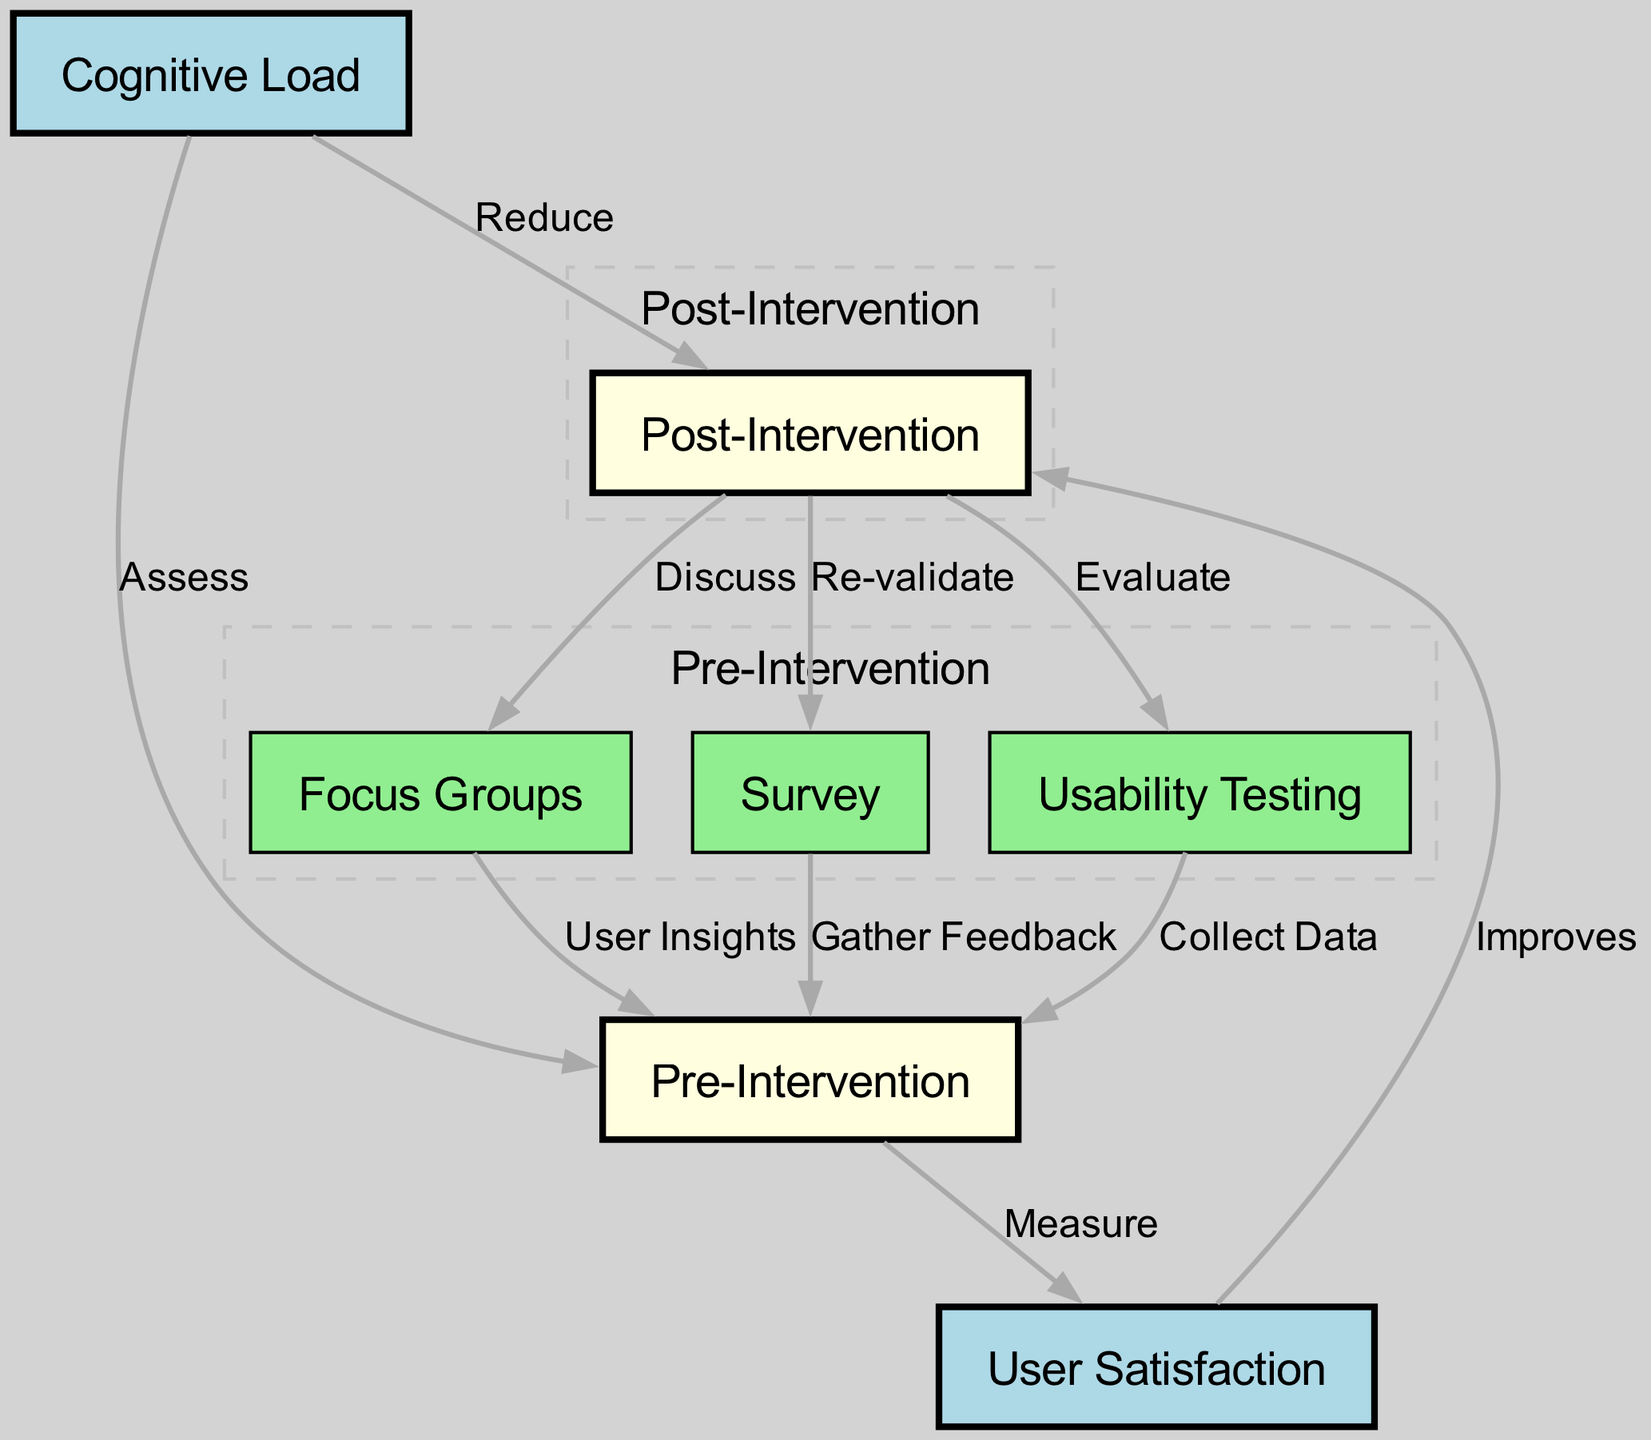What is the label of the node related to user satisfaction? The node related to user satisfaction is labeled "User Satisfaction", as indicated in the diagram with the specific node designation for user satisfaction.
Answer: User Satisfaction How many nodes are in the diagram? By counting all the nodes listed under "nodes", there are 6 nodes in total: User Satisfaction, Pre-Intervention, Post-Intervention, Cognitive Load, Usability Testing, Focus Groups, and Survey.
Answer: 6 What relationship exists between pre-intervention and user satisfaction? The edge connecting the pre-intervention node to the user satisfaction node is labeled "Measure", indicating that pre-intervention activities involve measuring user satisfaction.
Answer: Measure Which techniques collect data before the intervention? The nodes usability testing, focus groups, and survey are all connected to pre-intervention, indicating that they are techniques used to collect data prior to the intervention.
Answer: Usability Testing, Focus Groups, Survey How does cognitive load relate to post-intervention? The edge from cognitive load to post-intervention is labeled "Reduce", indicating that after the intervention, the aim is to reduce cognitive load for users, connecting both concepts.
Answer: Reduce What is evaluated after the post-intervention phase? The node labeled usability testing is connected to post-intervention with "Evaluate", suggesting that usability testing is performed to assess the effectiveness after the intervention occurs.
Answer: Evaluate What label indicates the purpose of post-intervention surveys? The edge from post-intervention to survey is labeled "Re-validate", indicating the purpose of surveys during the post-intervention phase is to re-validate findings or improvements.
Answer: Re-validate What can be inferred about user satisfaction after the intervention? The edge from user satisfaction to post-intervention is labeled "Improves", suggesting a positive impact on user satisfaction as a result of the intervention having taken place.
Answer: Improves 